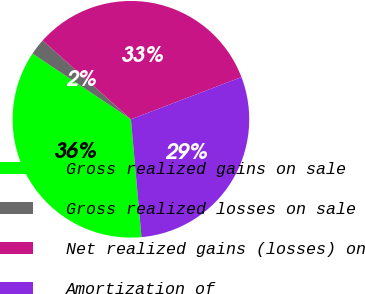Convert chart to OTSL. <chart><loc_0><loc_0><loc_500><loc_500><pie_chart><fcel>Gross realized gains on sale<fcel>Gross realized losses on sale<fcel>Net realized gains (losses) on<fcel>Amortization of<nl><fcel>35.79%<fcel>2.24%<fcel>32.59%<fcel>29.38%<nl></chart> 